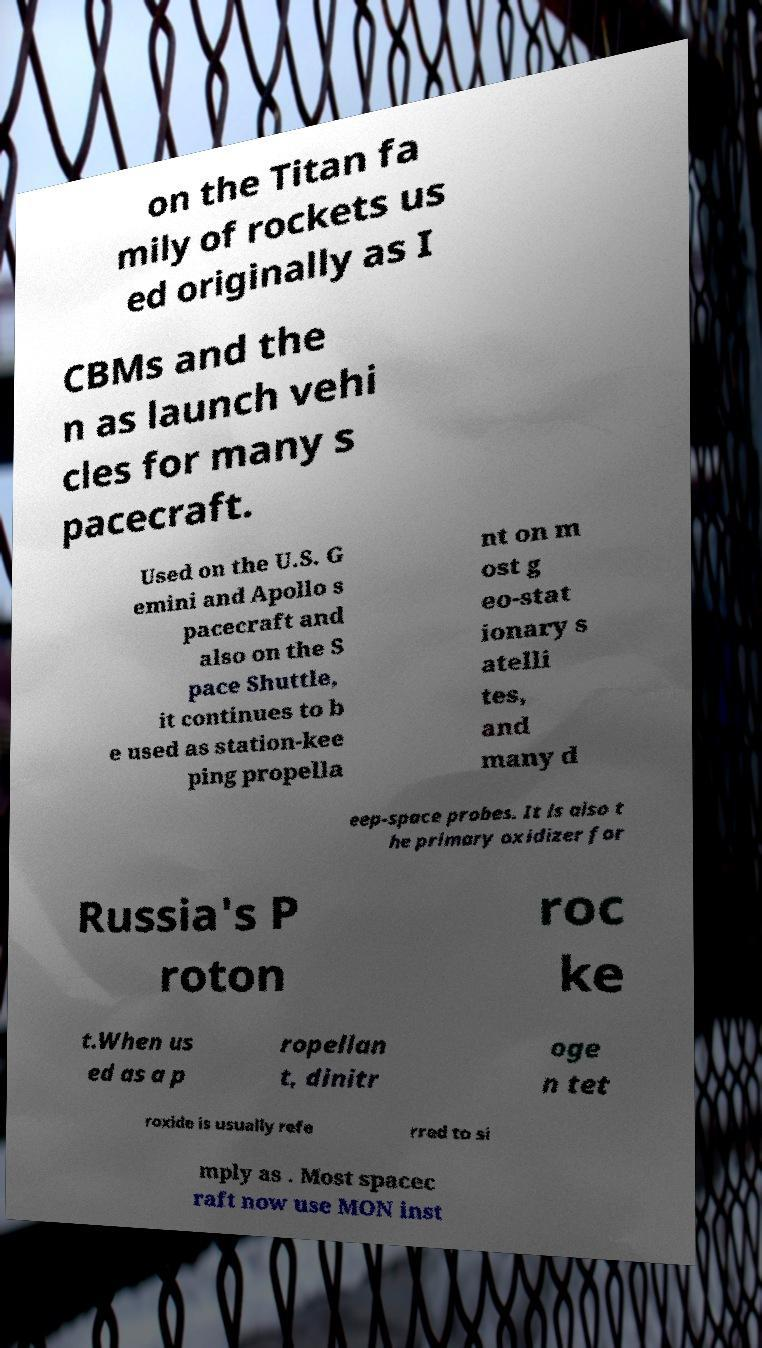I need the written content from this picture converted into text. Can you do that? on the Titan fa mily of rockets us ed originally as I CBMs and the n as launch vehi cles for many s pacecraft. Used on the U.S. G emini and Apollo s pacecraft and also on the S pace Shuttle, it continues to b e used as station-kee ping propella nt on m ost g eo-stat ionary s atelli tes, and many d eep-space probes. It is also t he primary oxidizer for Russia's P roton roc ke t.When us ed as a p ropellan t, dinitr oge n tet roxide is usually refe rred to si mply as . Most spacec raft now use MON inst 